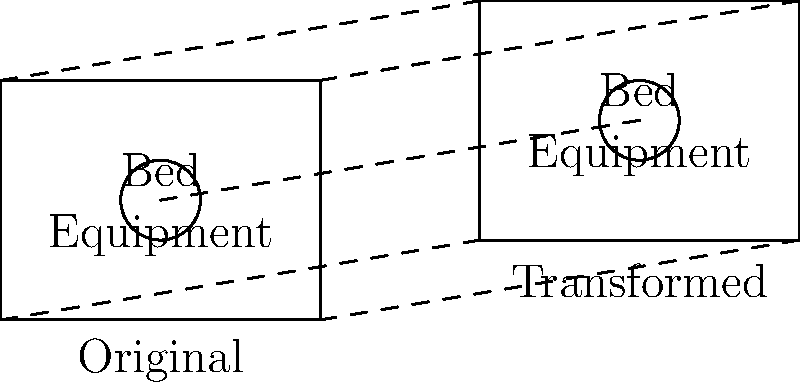In a hospital room layout, medical equipment needs to be rearranged. The original position of the equipment is at (2, 1.5) in a coordinate system where each unit represents 1 meter. The new layout requires the equipment to be translated 6 units to the right and 1 unit up, then rotated 90° clockwise around the point (8, 2.5). What is the final position of the equipment after this composite transformation? Let's break this down step-by-step:

1) The original position of the equipment is (2, 1.5).

2) First, we apply the translation:
   - 6 units to the right: x-coordinate changes from 2 to 2 + 6 = 8
   - 1 unit up: y-coordinate changes from 1.5 to 1.5 + 1 = 2.5
   After translation, the position is (8, 2.5).

3) Next, we need to rotate 90° clockwise around the point (8, 2.5).
   - The point (8, 2.5) is already at this position, so it will remain unchanged after rotation.
   - A 90° clockwise rotation around a point (a, b) can be represented by the transformation:
     $$(x, y) \rightarrow (a + (y - b), b - (x - a))$$

4) Applying this rotation formula with (a, b) = (8, 2.5) and (x, y) = (8, 2.5):
   $$x_{new} = 8 + (2.5 - 2.5) = 8$$
   $$y_{new} = 2.5 - (8 - 8) = 2.5$$

5) Therefore, the final position after both transformations is (8, 2.5).
Answer: (8, 2.5) 